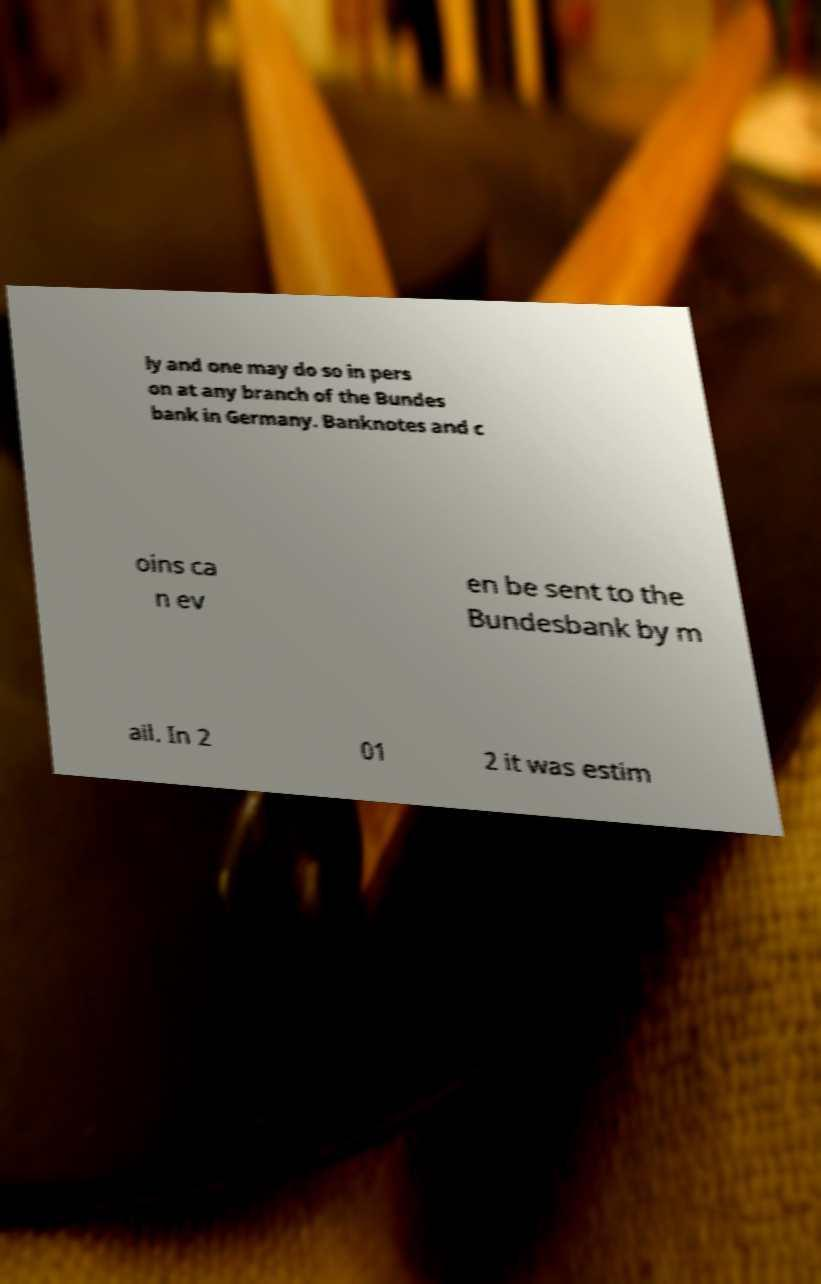What messages or text are displayed in this image? I need them in a readable, typed format. ly and one may do so in pers on at any branch of the Bundes bank in Germany. Banknotes and c oins ca n ev en be sent to the Bundesbank by m ail. In 2 01 2 it was estim 